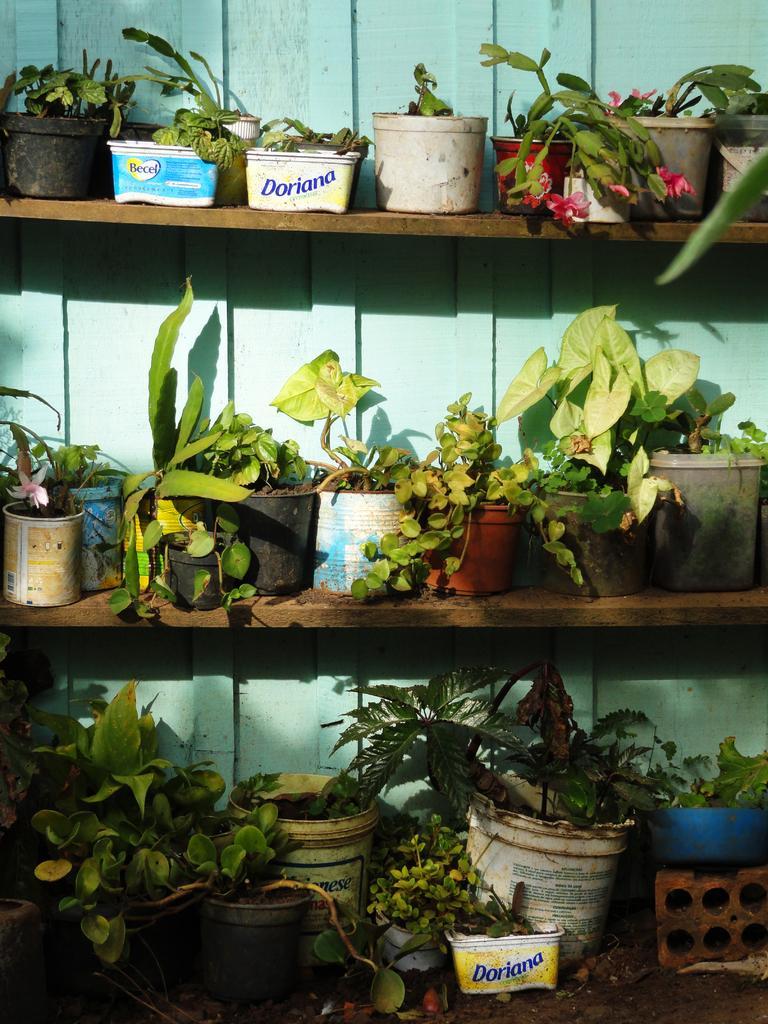Could you give a brief overview of what you see in this image? In this image, we can see shelves, there are some flower pots kept on the shelves, we can see the wall. 